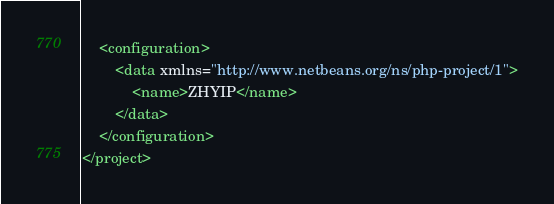<code> <loc_0><loc_0><loc_500><loc_500><_XML_>    <configuration>
        <data xmlns="http://www.netbeans.org/ns/php-project/1">
            <name>ZHYIP</name>
        </data>
    </configuration>
</project>
</code> 